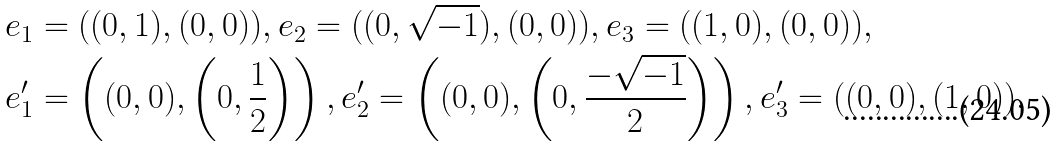<formula> <loc_0><loc_0><loc_500><loc_500>e _ { 1 } & = ( ( 0 , 1 ) , ( 0 , 0 ) ) , e _ { 2 } = ( ( 0 , \sqrt { - 1 } ) , ( 0 , 0 ) ) , e _ { 3 } = ( ( 1 , 0 ) , ( 0 , 0 ) ) , \\ e _ { 1 } ^ { \prime } & = \left ( ( 0 , 0 ) , \left ( 0 , \frac { 1 } { 2 } \right ) \right ) , e _ { 2 } ^ { \prime } = \left ( ( 0 , 0 ) , \left ( 0 , \frac { - \sqrt { - 1 } } { 2 } \right ) \right ) , e _ { 3 } ^ { \prime } = ( ( 0 , 0 ) , ( 1 , 0 ) ) .</formula> 